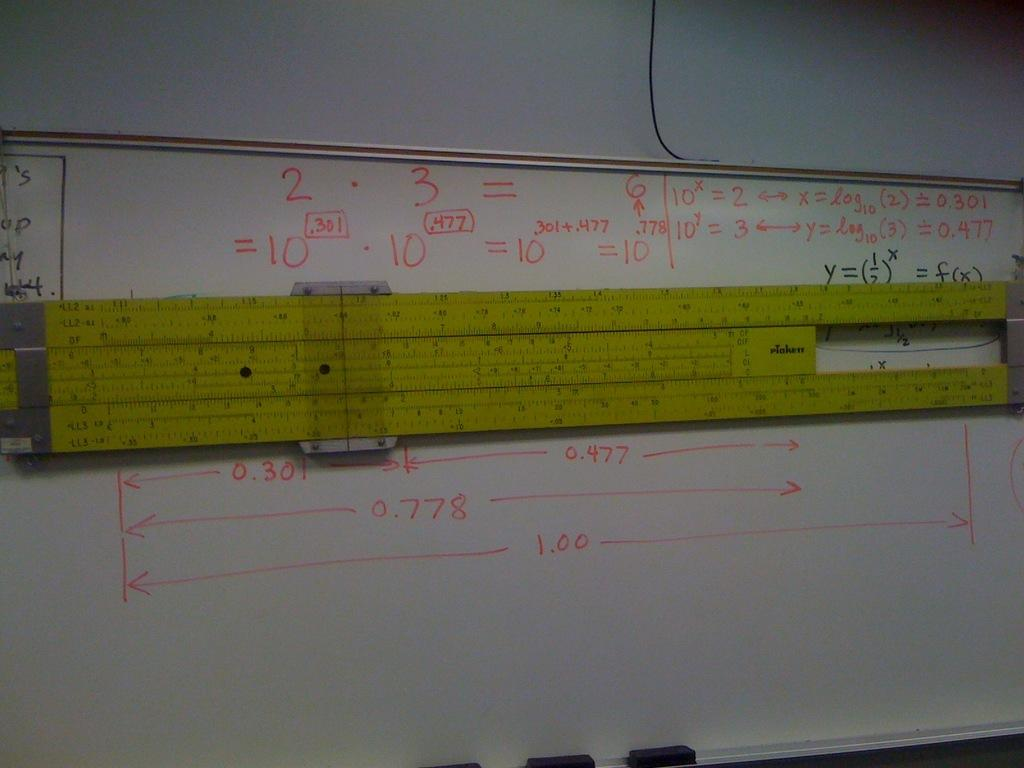<image>
Write a terse but informative summary of the picture. a white board with the number 3 on it 